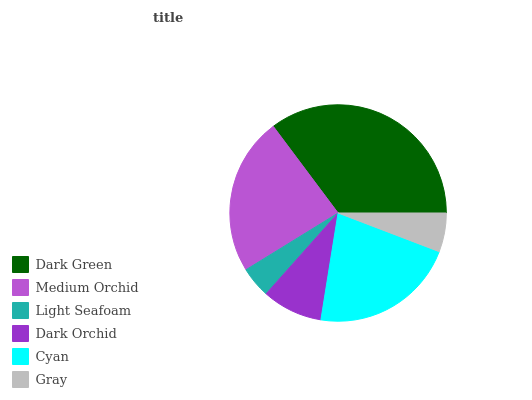Is Light Seafoam the minimum?
Answer yes or no. Yes. Is Dark Green the maximum?
Answer yes or no. Yes. Is Medium Orchid the minimum?
Answer yes or no. No. Is Medium Orchid the maximum?
Answer yes or no. No. Is Dark Green greater than Medium Orchid?
Answer yes or no. Yes. Is Medium Orchid less than Dark Green?
Answer yes or no. Yes. Is Medium Orchid greater than Dark Green?
Answer yes or no. No. Is Dark Green less than Medium Orchid?
Answer yes or no. No. Is Cyan the high median?
Answer yes or no. Yes. Is Dark Orchid the low median?
Answer yes or no. Yes. Is Dark Orchid the high median?
Answer yes or no. No. Is Medium Orchid the low median?
Answer yes or no. No. 